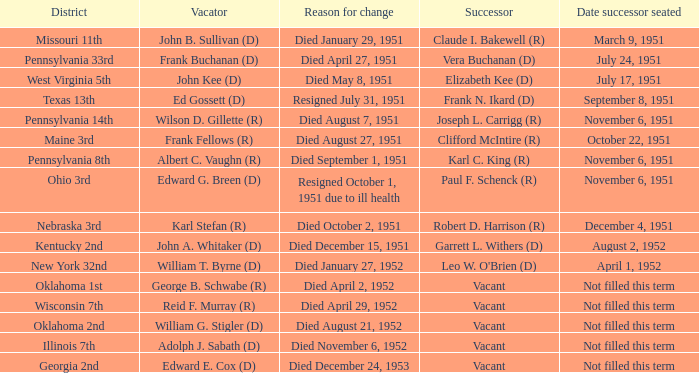What was the number of vacators in the 33rd district of pennsylvania? 1.0. 